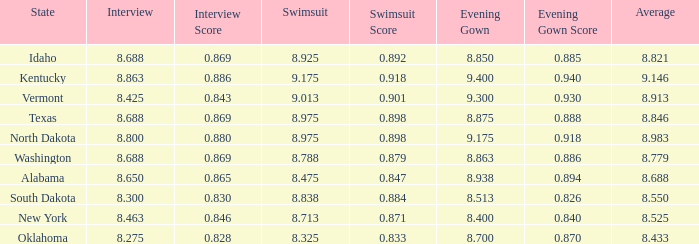Who had the lowest interview score from South Dakota with an evening gown less than 8.513? None. 